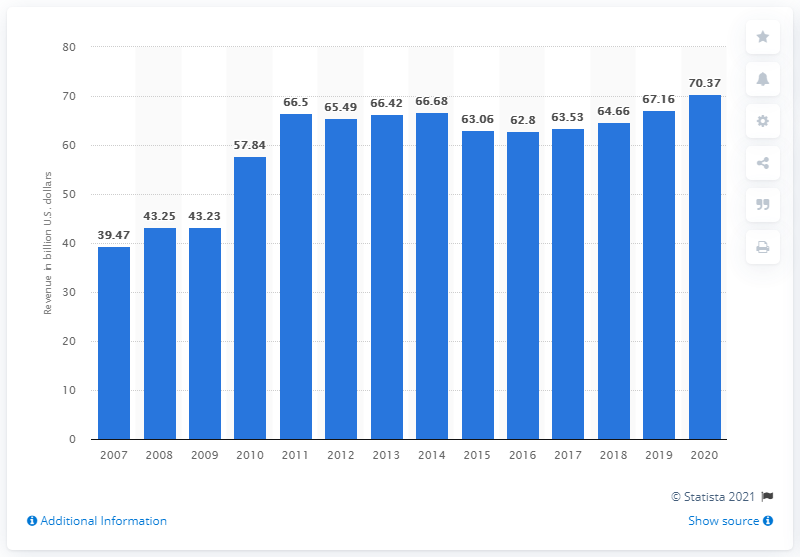Draw attention to some important aspects in this diagram. In 2020, PepsiCo's net revenue worldwide was approximately 70.37 billion dollars. 